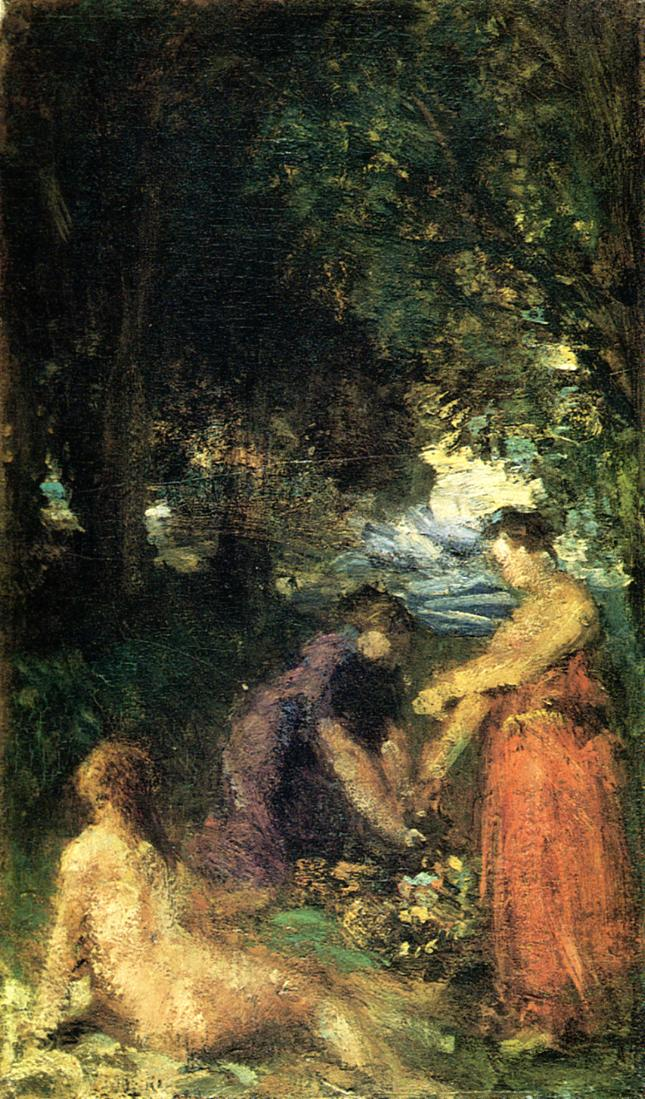What do you think is going on in this snapshot? This image depicts an evocative impressionist painting, where figures emerge from a lush forest landscape. We notice a play of light and shadow through the trees, striking a juxtaposition that adds depth to the composition. The artist used a blend of vivid and subdued colors to create a dynamic atmosphere. While the foreground is characterized by better-defined forms, there's a deliberate haziness in the background that is typical of the Impressionist movement, which sought to capture the essence of a moment. The scene suggests a serene encounter in nature, possibly reflecting the human connection to the environment and the simplicity of pastoral life. 